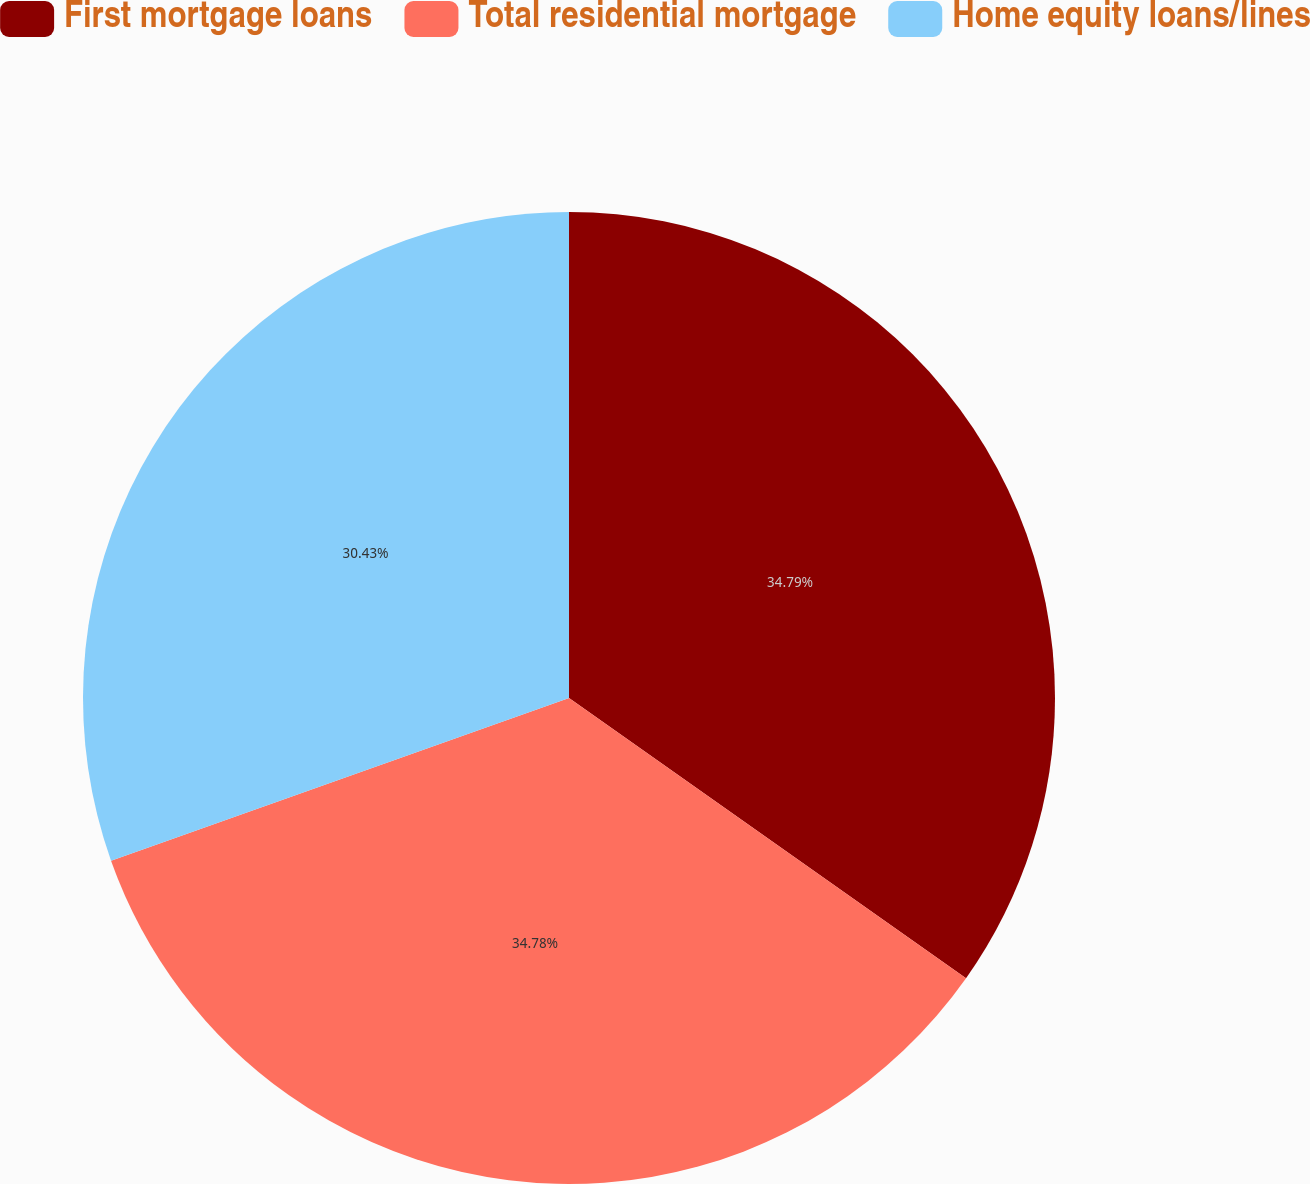Convert chart to OTSL. <chart><loc_0><loc_0><loc_500><loc_500><pie_chart><fcel>First mortgage loans<fcel>Total residential mortgage<fcel>Home equity loans/lines<nl><fcel>34.78%<fcel>34.78%<fcel>30.43%<nl></chart> 